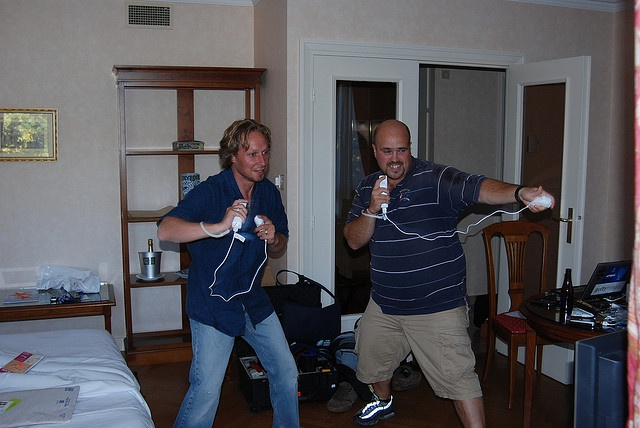Describe the objects in this image and their specific colors. I can see people in gray, black, maroon, and navy tones, people in gray, black, navy, and blue tones, bed in gray and darkgray tones, chair in gray, black, and maroon tones, and dining table in gray, black, and navy tones in this image. 